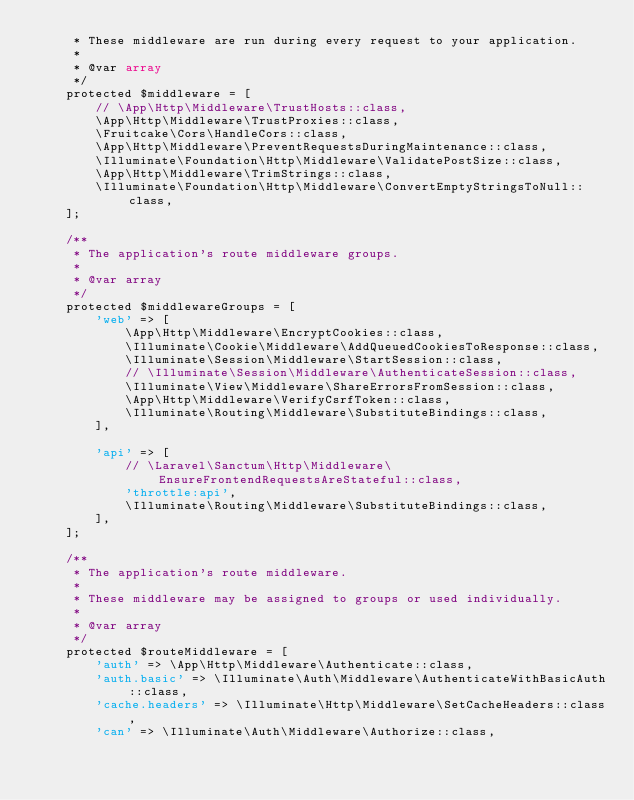Convert code to text. <code><loc_0><loc_0><loc_500><loc_500><_PHP_>     * These middleware are run during every request to your application.
     *
     * @var array
     */
    protected $middleware = [
        // \App\Http\Middleware\TrustHosts::class,
        \App\Http\Middleware\TrustProxies::class,
        \Fruitcake\Cors\HandleCors::class,
        \App\Http\Middleware\PreventRequestsDuringMaintenance::class,
        \Illuminate\Foundation\Http\Middleware\ValidatePostSize::class,
        \App\Http\Middleware\TrimStrings::class,
        \Illuminate\Foundation\Http\Middleware\ConvertEmptyStringsToNull::class,
    ];

    /**
     * The application's route middleware groups.
     *
     * @var array
     */
    protected $middlewareGroups = [
        'web' => [
            \App\Http\Middleware\EncryptCookies::class,
            \Illuminate\Cookie\Middleware\AddQueuedCookiesToResponse::class,
            \Illuminate\Session\Middleware\StartSession::class,
            // \Illuminate\Session\Middleware\AuthenticateSession::class,
            \Illuminate\View\Middleware\ShareErrorsFromSession::class,
            \App\Http\Middleware\VerifyCsrfToken::class,
            \Illuminate\Routing\Middleware\SubstituteBindings::class,
        ],

        'api' => [
            // \Laravel\Sanctum\Http\Middleware\EnsureFrontendRequestsAreStateful::class,
            'throttle:api',
            \Illuminate\Routing\Middleware\SubstituteBindings::class,
        ],
    ];

    /**
     * The application's route middleware.
     *
     * These middleware may be assigned to groups or used individually.
     *
     * @var array
     */
    protected $routeMiddleware = [
        'auth' => \App\Http\Middleware\Authenticate::class,
        'auth.basic' => \Illuminate\Auth\Middleware\AuthenticateWithBasicAuth::class,
        'cache.headers' => \Illuminate\Http\Middleware\SetCacheHeaders::class,
        'can' => \Illuminate\Auth\Middleware\Authorize::class,</code> 